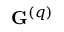<formula> <loc_0><loc_0><loc_500><loc_500>G ^ { \left ( q \right ) }</formula> 